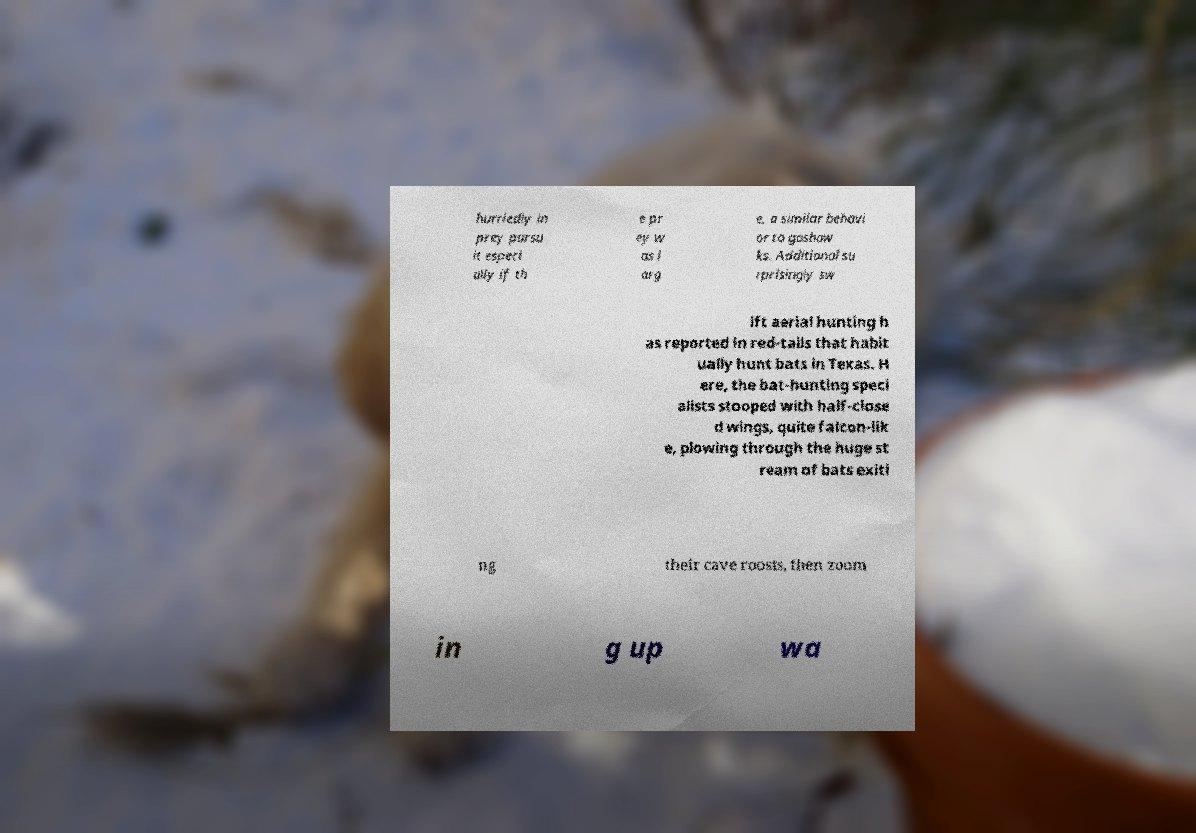Can you accurately transcribe the text from the provided image for me? hurriedly in prey pursu it especi ally if th e pr ey w as l arg e, a similar behavi or to goshaw ks. Additional su rprisingly sw ift aerial hunting h as reported in red-tails that habit ually hunt bats in Texas. H ere, the bat-hunting speci alists stooped with half-close d wings, quite falcon-lik e, plowing through the huge st ream of bats exiti ng their cave roosts, then zoom in g up wa 